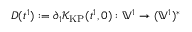Convert formula to latex. <formula><loc_0><loc_0><loc_500><loc_500>D ( t ^ { 1 } ) \colon = \partial _ { 1 } \mathcal { K } _ { K P } ( t ^ { 1 } , 0 ) \colon \mathbb { V } ^ { 1 } \to ( \mathbb { V } ^ { 1 } ) ^ { * }</formula> 